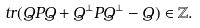<formula> <loc_0><loc_0><loc_500><loc_500>\ t r ( Q P Q + Q ^ { \perp } P Q ^ { \perp } - Q ) \in \mathbb { Z } .</formula> 